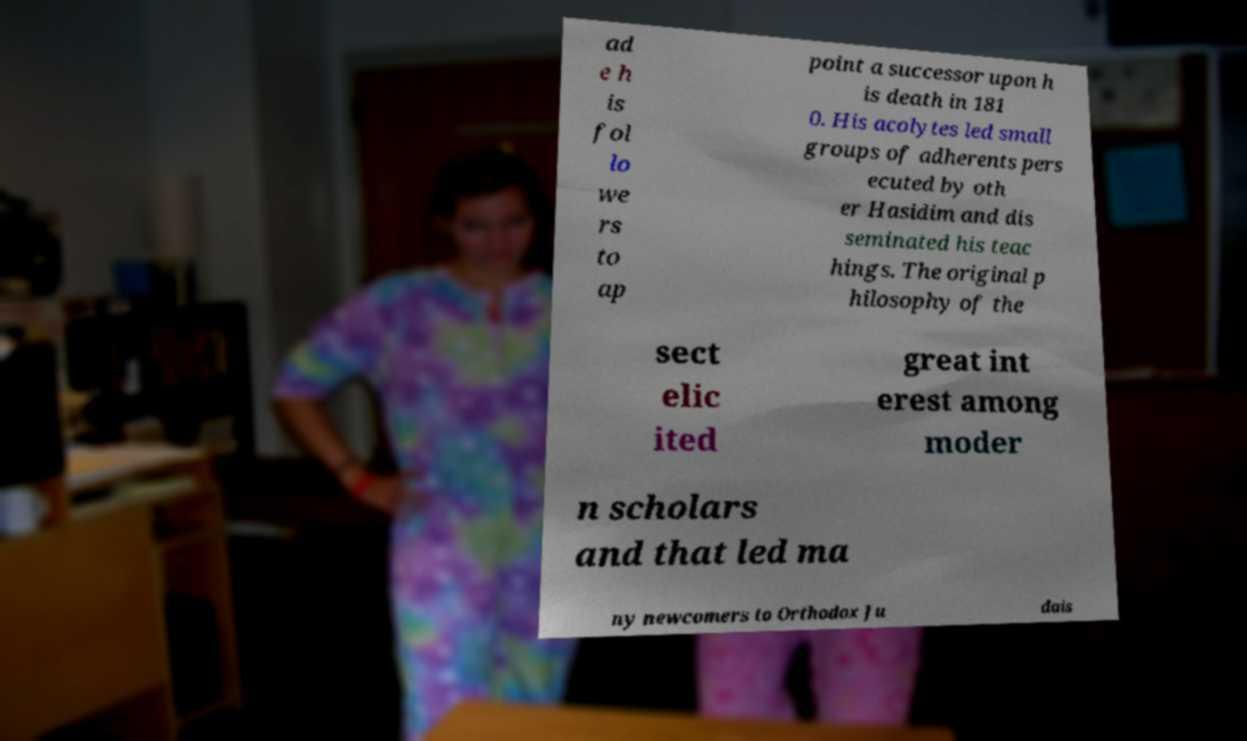For documentation purposes, I need the text within this image transcribed. Could you provide that? ad e h is fol lo we rs to ap point a successor upon h is death in 181 0. His acolytes led small groups of adherents pers ecuted by oth er Hasidim and dis seminated his teac hings. The original p hilosophy of the sect elic ited great int erest among moder n scholars and that led ma ny newcomers to Orthodox Ju dais 